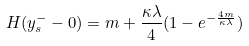Convert formula to latex. <formula><loc_0><loc_0><loc_500><loc_500>H ( y _ { s } ^ { - } - 0 ) = m + \frac { \kappa \lambda } { 4 } ( 1 - e ^ { - \frac { 4 m } { \kappa \lambda } } )</formula> 